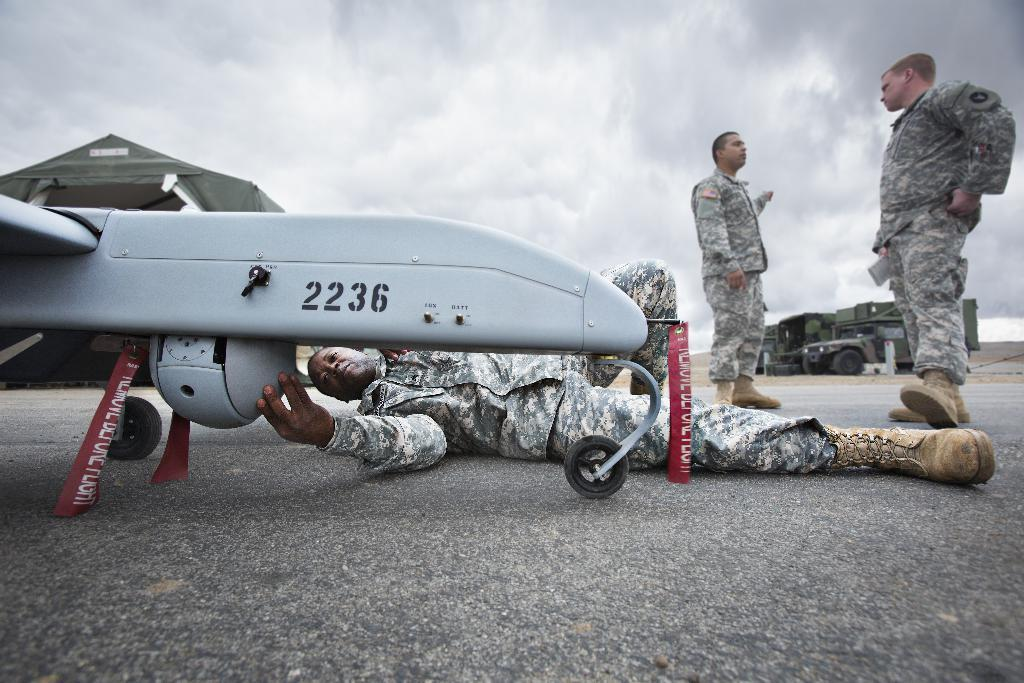<image>
Render a clear and concise summary of the photo. a man laying under the wing of a drone numbered 2236 